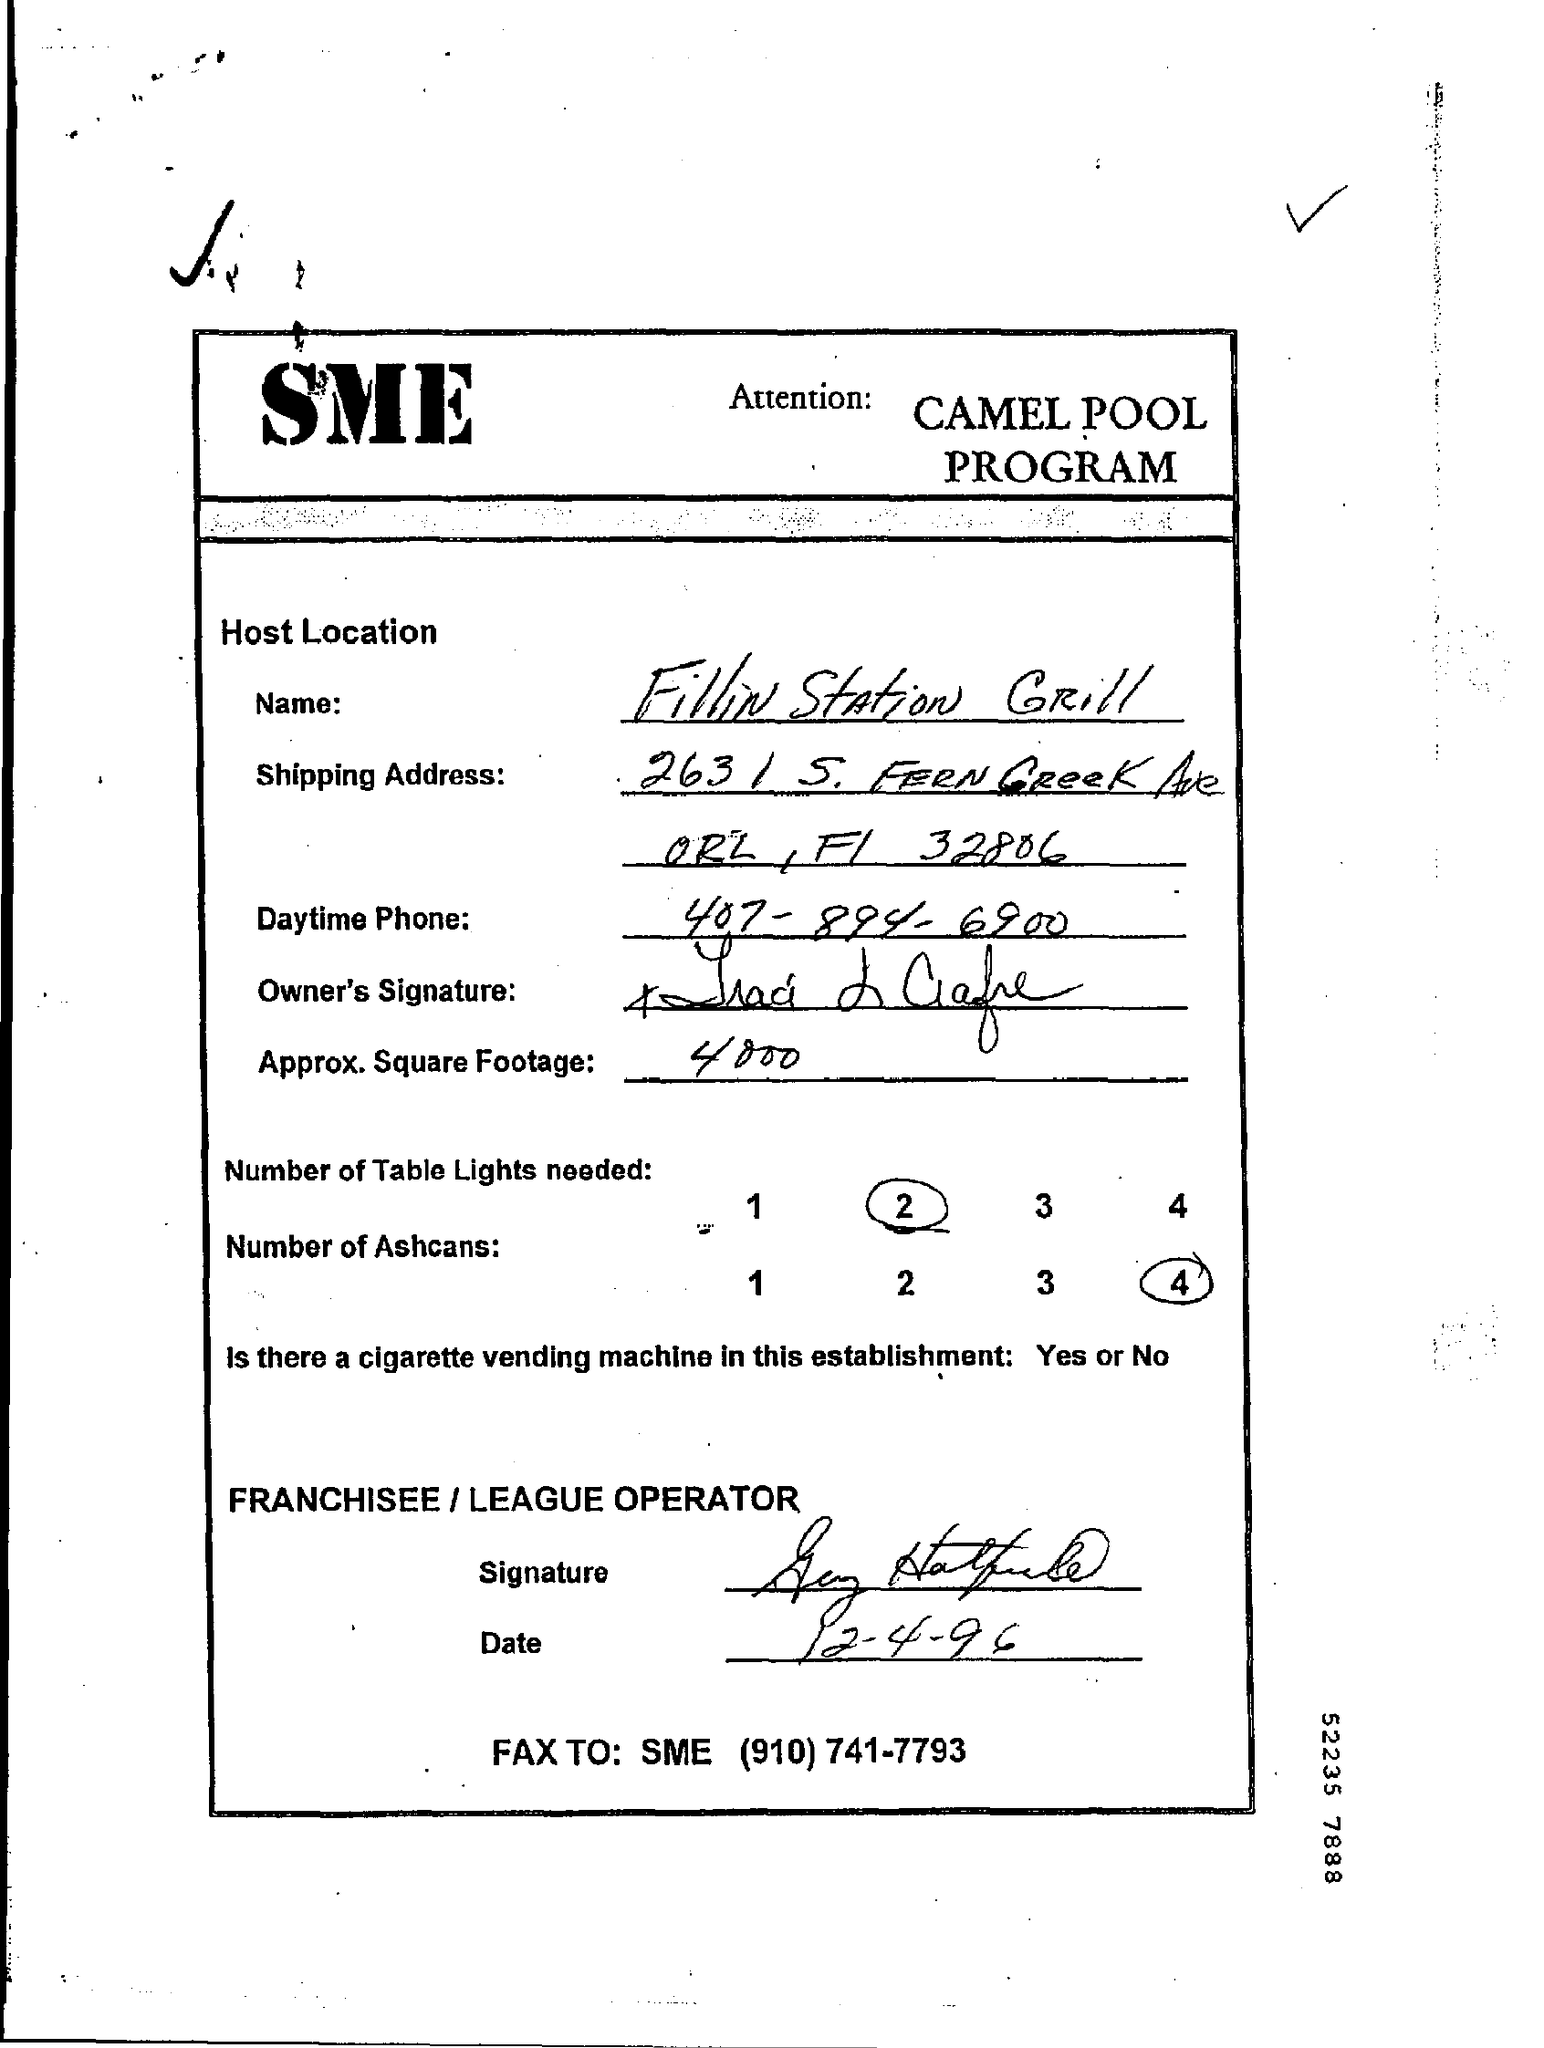What is the Host Location Name?
Your answer should be very brief. Fillin Station Grill. What is the Daytime Phone?
Keep it short and to the point. 407-894-6900. What is the Approx Square Footage?
Your response must be concise. 4000. What is the Number of Table Lights Needed?
Provide a succinct answer. 2. What is the Number of Ashcans?
Give a very brief answer. 4. What is the Date?
Your answer should be very brief. 12-4-96. What is the FAX TO: SME?
Offer a very short reply. (910) 741-7793. 